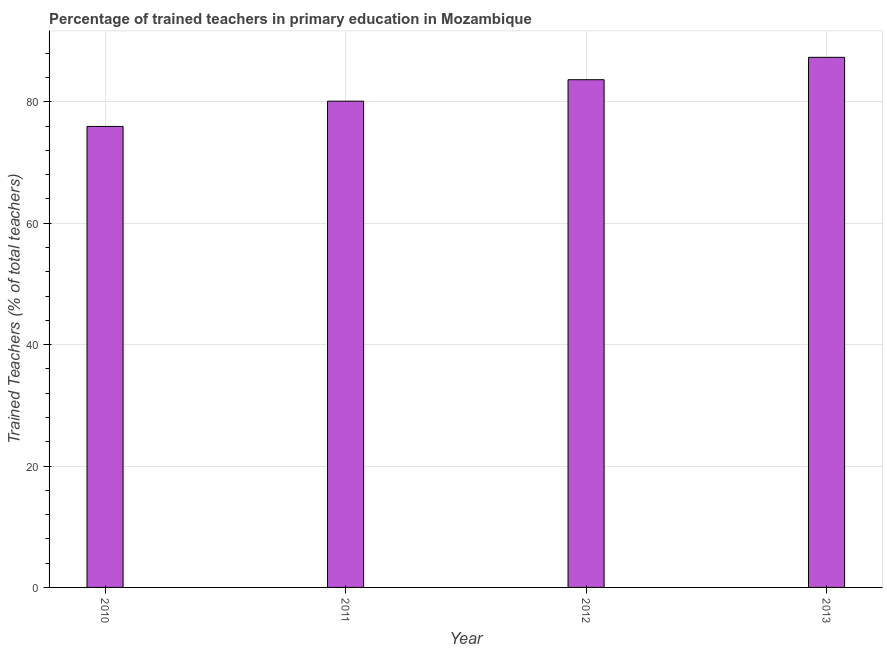What is the title of the graph?
Ensure brevity in your answer.  Percentage of trained teachers in primary education in Mozambique. What is the label or title of the X-axis?
Offer a very short reply. Year. What is the label or title of the Y-axis?
Offer a terse response. Trained Teachers (% of total teachers). What is the percentage of trained teachers in 2012?
Make the answer very short. 83.64. Across all years, what is the maximum percentage of trained teachers?
Ensure brevity in your answer.  87.33. Across all years, what is the minimum percentage of trained teachers?
Make the answer very short. 75.94. In which year was the percentage of trained teachers minimum?
Offer a very short reply. 2010. What is the sum of the percentage of trained teachers?
Offer a very short reply. 327.01. What is the difference between the percentage of trained teachers in 2011 and 2012?
Offer a terse response. -3.54. What is the average percentage of trained teachers per year?
Provide a succinct answer. 81.75. What is the median percentage of trained teachers?
Your answer should be very brief. 81.87. Do a majority of the years between 2011 and 2012 (inclusive) have percentage of trained teachers greater than 40 %?
Ensure brevity in your answer.  Yes. What is the ratio of the percentage of trained teachers in 2010 to that in 2013?
Give a very brief answer. 0.87. Is the percentage of trained teachers in 2010 less than that in 2013?
Your response must be concise. Yes. What is the difference between the highest and the second highest percentage of trained teachers?
Your response must be concise. 3.69. Is the sum of the percentage of trained teachers in 2011 and 2012 greater than the maximum percentage of trained teachers across all years?
Provide a short and direct response. Yes. What is the difference between the highest and the lowest percentage of trained teachers?
Ensure brevity in your answer.  11.38. In how many years, is the percentage of trained teachers greater than the average percentage of trained teachers taken over all years?
Give a very brief answer. 2. How many bars are there?
Your answer should be very brief. 4. Are all the bars in the graph horizontal?
Give a very brief answer. No. How many years are there in the graph?
Keep it short and to the point. 4. What is the difference between two consecutive major ticks on the Y-axis?
Give a very brief answer. 20. Are the values on the major ticks of Y-axis written in scientific E-notation?
Your response must be concise. No. What is the Trained Teachers (% of total teachers) in 2010?
Your answer should be very brief. 75.94. What is the Trained Teachers (% of total teachers) of 2011?
Your answer should be compact. 80.1. What is the Trained Teachers (% of total teachers) of 2012?
Offer a very short reply. 83.64. What is the Trained Teachers (% of total teachers) of 2013?
Ensure brevity in your answer.  87.33. What is the difference between the Trained Teachers (% of total teachers) in 2010 and 2011?
Ensure brevity in your answer.  -4.16. What is the difference between the Trained Teachers (% of total teachers) in 2010 and 2012?
Offer a very short reply. -7.7. What is the difference between the Trained Teachers (% of total teachers) in 2010 and 2013?
Your response must be concise. -11.38. What is the difference between the Trained Teachers (% of total teachers) in 2011 and 2012?
Give a very brief answer. -3.54. What is the difference between the Trained Teachers (% of total teachers) in 2011 and 2013?
Offer a very short reply. -7.22. What is the difference between the Trained Teachers (% of total teachers) in 2012 and 2013?
Give a very brief answer. -3.69. What is the ratio of the Trained Teachers (% of total teachers) in 2010 to that in 2011?
Make the answer very short. 0.95. What is the ratio of the Trained Teachers (% of total teachers) in 2010 to that in 2012?
Keep it short and to the point. 0.91. What is the ratio of the Trained Teachers (% of total teachers) in 2010 to that in 2013?
Provide a short and direct response. 0.87. What is the ratio of the Trained Teachers (% of total teachers) in 2011 to that in 2012?
Offer a very short reply. 0.96. What is the ratio of the Trained Teachers (% of total teachers) in 2011 to that in 2013?
Your answer should be compact. 0.92. What is the ratio of the Trained Teachers (% of total teachers) in 2012 to that in 2013?
Your response must be concise. 0.96. 